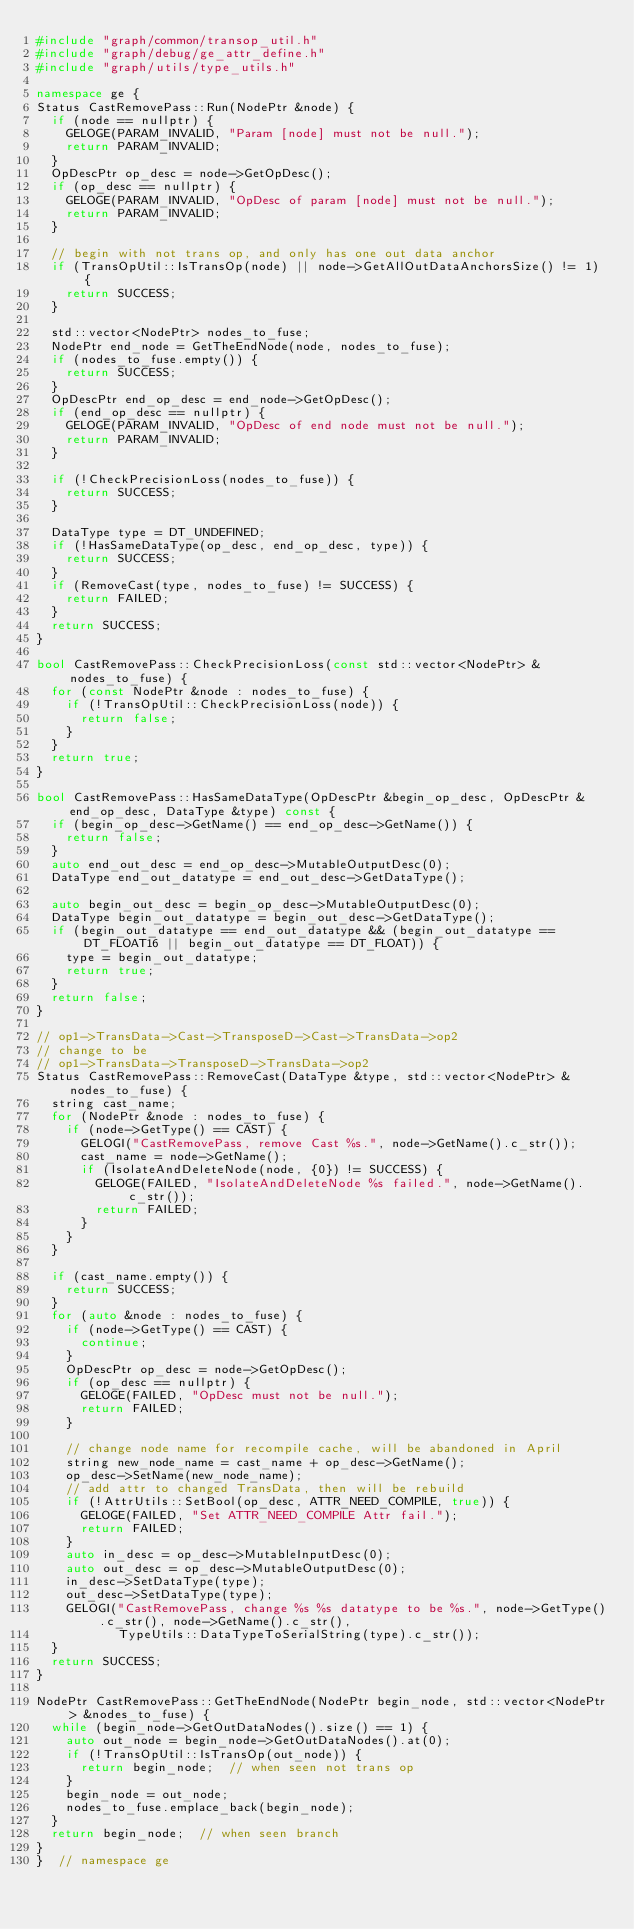<code> <loc_0><loc_0><loc_500><loc_500><_C++_>#include "graph/common/transop_util.h"
#include "graph/debug/ge_attr_define.h"
#include "graph/utils/type_utils.h"

namespace ge {
Status CastRemovePass::Run(NodePtr &node) {
  if (node == nullptr) {
    GELOGE(PARAM_INVALID, "Param [node] must not be null.");
    return PARAM_INVALID;
  }
  OpDescPtr op_desc = node->GetOpDesc();
  if (op_desc == nullptr) {
    GELOGE(PARAM_INVALID, "OpDesc of param [node] must not be null.");
    return PARAM_INVALID;
  }

  // begin with not trans op, and only has one out data anchor
  if (TransOpUtil::IsTransOp(node) || node->GetAllOutDataAnchorsSize() != 1) {
    return SUCCESS;
  }

  std::vector<NodePtr> nodes_to_fuse;
  NodePtr end_node = GetTheEndNode(node, nodes_to_fuse);
  if (nodes_to_fuse.empty()) {
    return SUCCESS;
  }
  OpDescPtr end_op_desc = end_node->GetOpDesc();
  if (end_op_desc == nullptr) {
    GELOGE(PARAM_INVALID, "OpDesc of end node must not be null.");
    return PARAM_INVALID;
  }

  if (!CheckPrecisionLoss(nodes_to_fuse)) {
    return SUCCESS;
  }

  DataType type = DT_UNDEFINED;
  if (!HasSameDataType(op_desc, end_op_desc, type)) {
    return SUCCESS;
  }
  if (RemoveCast(type, nodes_to_fuse) != SUCCESS) {
    return FAILED;
  }
  return SUCCESS;
}

bool CastRemovePass::CheckPrecisionLoss(const std::vector<NodePtr> &nodes_to_fuse) {
  for (const NodePtr &node : nodes_to_fuse) {
    if (!TransOpUtil::CheckPrecisionLoss(node)) {
      return false;
    }
  }
  return true;
}

bool CastRemovePass::HasSameDataType(OpDescPtr &begin_op_desc, OpDescPtr &end_op_desc, DataType &type) const {
  if (begin_op_desc->GetName() == end_op_desc->GetName()) {
    return false;
  }
  auto end_out_desc = end_op_desc->MutableOutputDesc(0);
  DataType end_out_datatype = end_out_desc->GetDataType();

  auto begin_out_desc = begin_op_desc->MutableOutputDesc(0);
  DataType begin_out_datatype = begin_out_desc->GetDataType();
  if (begin_out_datatype == end_out_datatype && (begin_out_datatype == DT_FLOAT16 || begin_out_datatype == DT_FLOAT)) {
    type = begin_out_datatype;
    return true;
  }
  return false;
}

// op1->TransData->Cast->TransposeD->Cast->TransData->op2
// change to be
// op1->TransData->TransposeD->TransData->op2
Status CastRemovePass::RemoveCast(DataType &type, std::vector<NodePtr> &nodes_to_fuse) {
  string cast_name;
  for (NodePtr &node : nodes_to_fuse) {
    if (node->GetType() == CAST) {
      GELOGI("CastRemovePass, remove Cast %s.", node->GetName().c_str());
      cast_name = node->GetName();
      if (IsolateAndDeleteNode(node, {0}) != SUCCESS) {
        GELOGE(FAILED, "IsolateAndDeleteNode %s failed.", node->GetName().c_str());
        return FAILED;
      }
    }
  }

  if (cast_name.empty()) {
    return SUCCESS;
  }
  for (auto &node : nodes_to_fuse) {
    if (node->GetType() == CAST) {
      continue;
    }
    OpDescPtr op_desc = node->GetOpDesc();
    if (op_desc == nullptr) {
      GELOGE(FAILED, "OpDesc must not be null.");
      return FAILED;
    }

    // change node name for recompile cache, will be abandoned in April
    string new_node_name = cast_name + op_desc->GetName();
    op_desc->SetName(new_node_name);
    // add attr to changed TransData, then will be rebuild
    if (!AttrUtils::SetBool(op_desc, ATTR_NEED_COMPILE, true)) {
      GELOGE(FAILED, "Set ATTR_NEED_COMPILE Attr fail.");
      return FAILED;
    }
    auto in_desc = op_desc->MutableInputDesc(0);
    auto out_desc = op_desc->MutableOutputDesc(0);
    in_desc->SetDataType(type);
    out_desc->SetDataType(type);
    GELOGI("CastRemovePass, change %s %s datatype to be %s.", node->GetType().c_str(), node->GetName().c_str(),
           TypeUtils::DataTypeToSerialString(type).c_str());
  }
  return SUCCESS;
}

NodePtr CastRemovePass::GetTheEndNode(NodePtr begin_node, std::vector<NodePtr> &nodes_to_fuse) {
  while (begin_node->GetOutDataNodes().size() == 1) {
    auto out_node = begin_node->GetOutDataNodes().at(0);
    if (!TransOpUtil::IsTransOp(out_node)) {
      return begin_node;  // when seen not trans op
    }
    begin_node = out_node;
    nodes_to_fuse.emplace_back(begin_node);
  }
  return begin_node;  // when seen branch
}
}  // namespace ge
</code> 